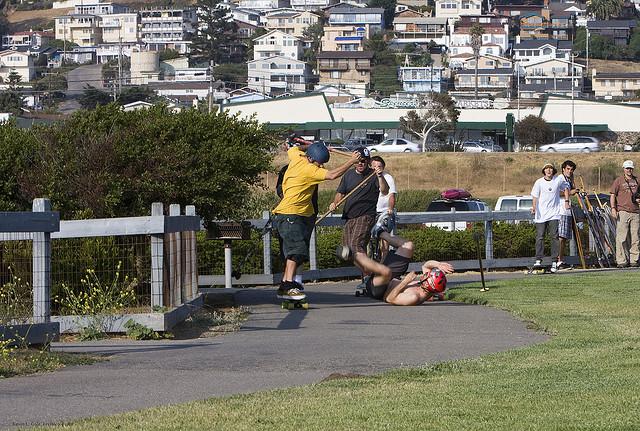Did the man in the red helmet fall?
Concise answer only. Yes. What color are the second mans shorts?
Concise answer only. Brown. What sport is being played?
Give a very brief answer. Skateboarding. Are they playing on grass?
Answer briefly. No. Is there houses in the background?
Concise answer only. Yes. 